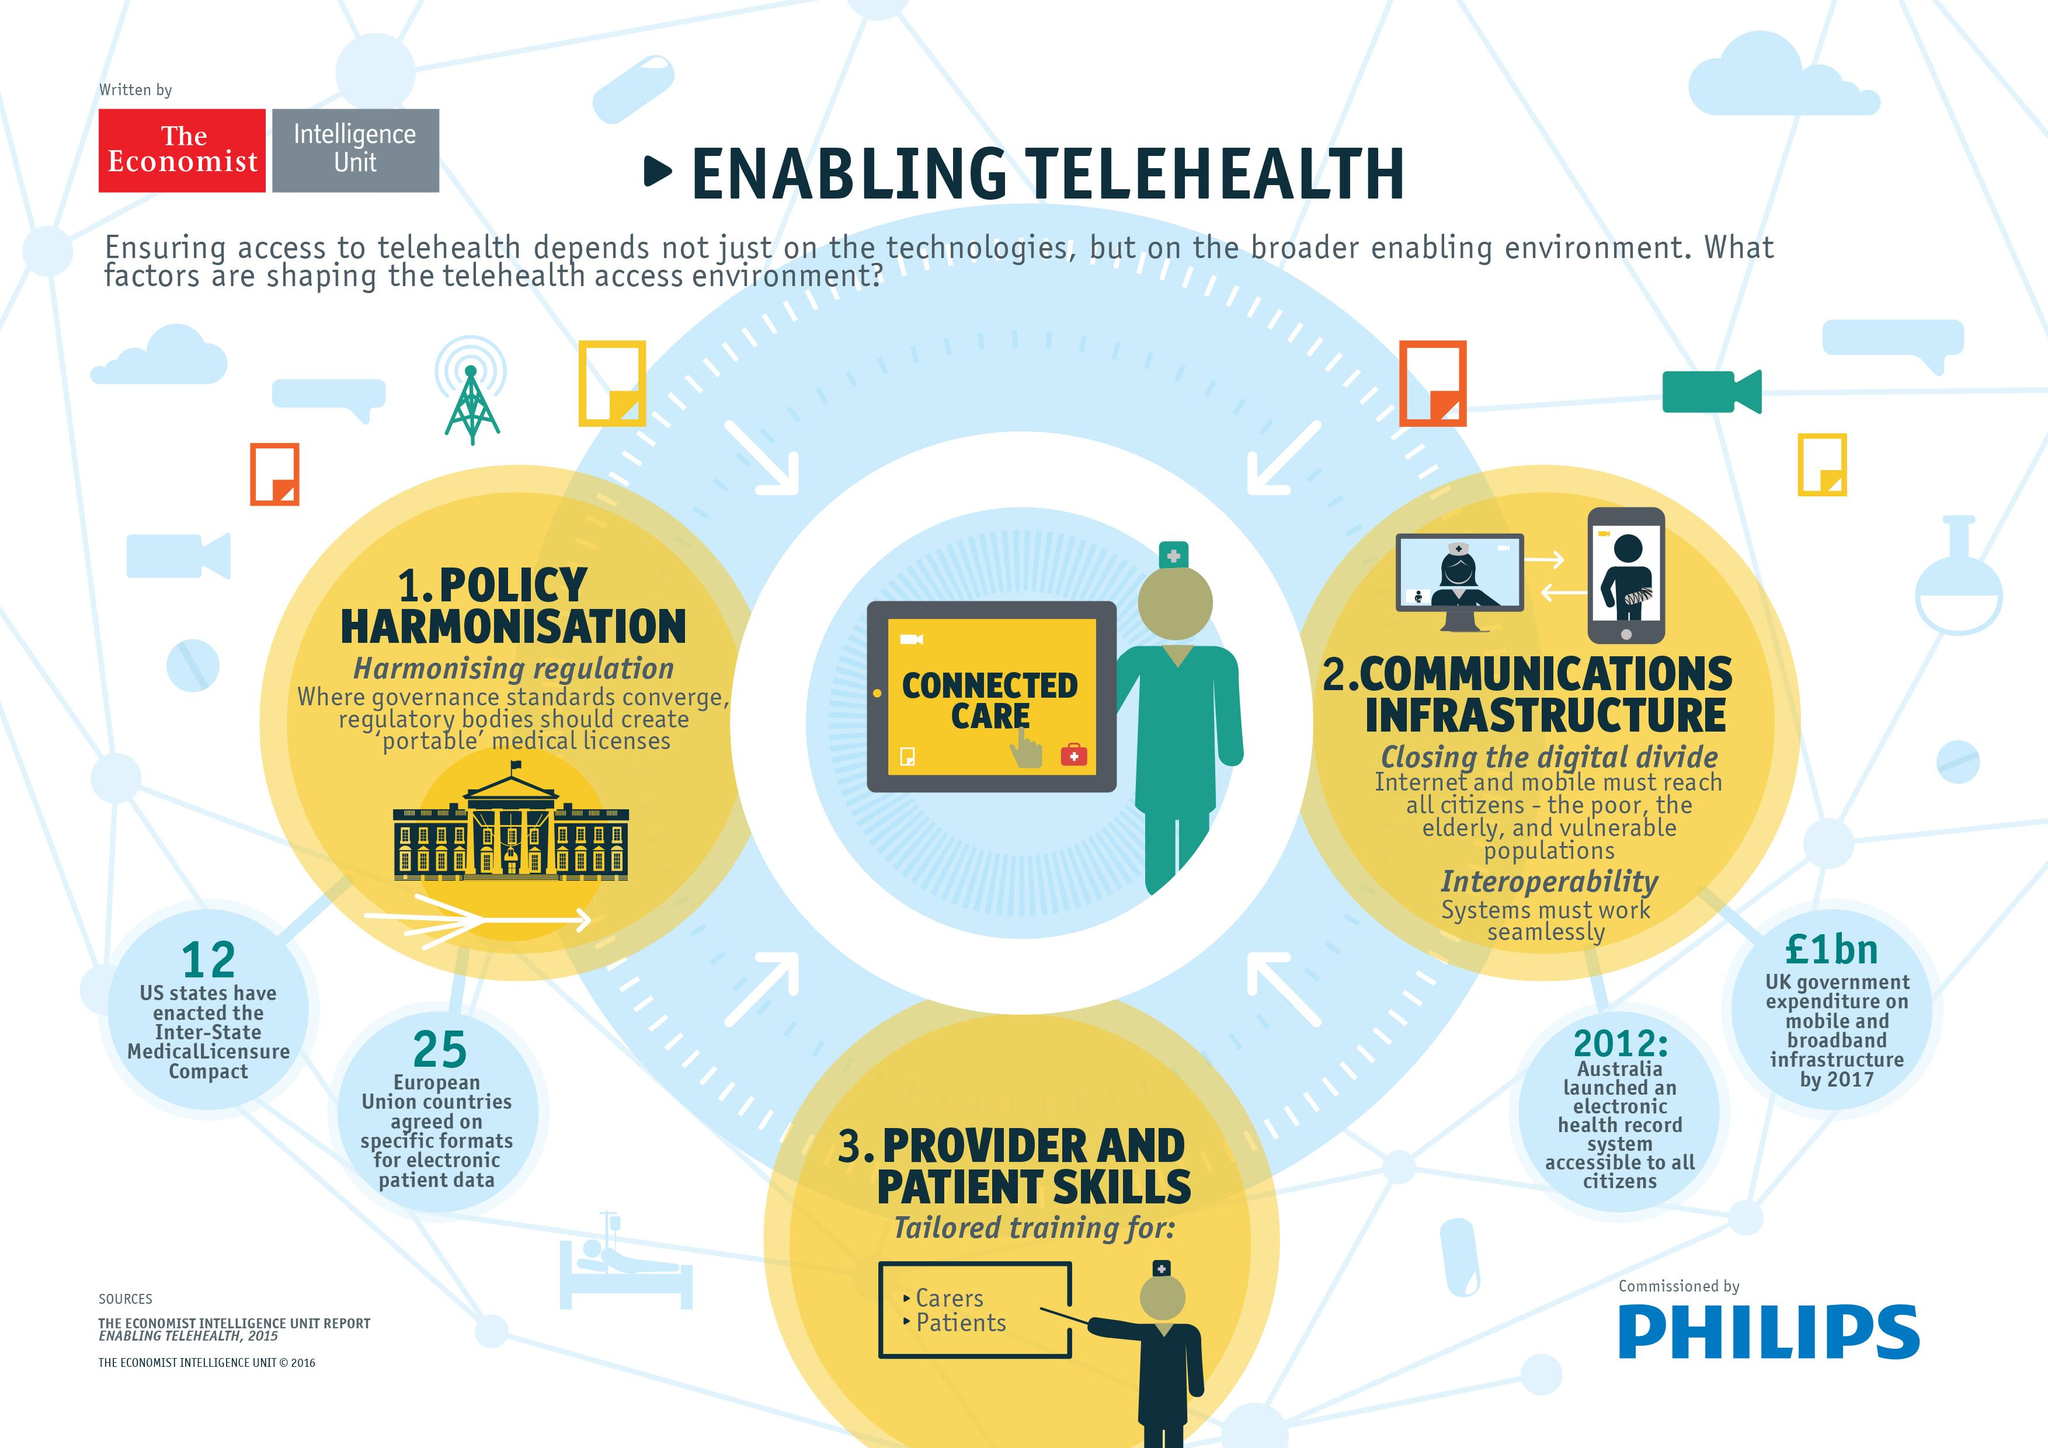Outline some significant characteristics in this image. Twelve US states have enacted the Inter-State Medical Licensure compact. The European Union has 25 member states that have agreed on specific formats for electronic patient data. 